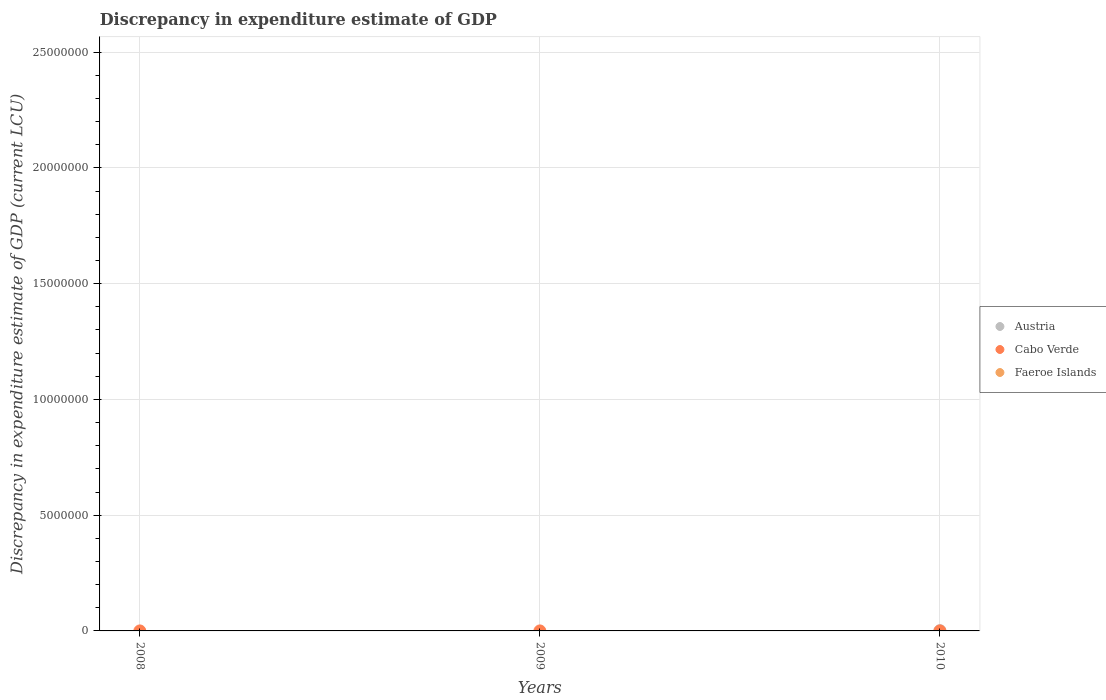How many different coloured dotlines are there?
Provide a short and direct response. 2. What is the discrepancy in expenditure estimate of GDP in Faeroe Islands in 2008?
Your answer should be compact. 0. What is the difference between the discrepancy in expenditure estimate of GDP in Cabo Verde in 2008 and that in 2009?
Your response must be concise. -100. What is the difference between the discrepancy in expenditure estimate of GDP in Cabo Verde in 2009 and the discrepancy in expenditure estimate of GDP in Austria in 2010?
Provide a short and direct response. -9900. What is the average discrepancy in expenditure estimate of GDP in Austria per year?
Offer a terse response. 3333.33. In how many years, is the discrepancy in expenditure estimate of GDP in Faeroe Islands greater than the average discrepancy in expenditure estimate of GDP in Faeroe Islands taken over all years?
Provide a short and direct response. 0. Is the sum of the discrepancy in expenditure estimate of GDP in Cabo Verde in 2008 and 2009 greater than the maximum discrepancy in expenditure estimate of GDP in Faeroe Islands across all years?
Ensure brevity in your answer.  Yes. Does the discrepancy in expenditure estimate of GDP in Faeroe Islands monotonically increase over the years?
Offer a terse response. No. Is the discrepancy in expenditure estimate of GDP in Faeroe Islands strictly less than the discrepancy in expenditure estimate of GDP in Cabo Verde over the years?
Your answer should be very brief. Yes. What is the difference between two consecutive major ticks on the Y-axis?
Your answer should be very brief. 5.00e+06. Are the values on the major ticks of Y-axis written in scientific E-notation?
Ensure brevity in your answer.  No. Does the graph contain grids?
Provide a short and direct response. Yes. How many legend labels are there?
Your answer should be very brief. 3. What is the title of the graph?
Keep it short and to the point. Discrepancy in expenditure estimate of GDP. What is the label or title of the Y-axis?
Keep it short and to the point. Discrepancy in expenditure estimate of GDP (current LCU). What is the Discrepancy in expenditure estimate of GDP (current LCU) in Austria in 2008?
Offer a very short reply. 0. What is the Discrepancy in expenditure estimate of GDP (current LCU) in Cabo Verde in 2008?
Offer a terse response. 9e-6. What is the Discrepancy in expenditure estimate of GDP (current LCU) in Austria in 2009?
Provide a short and direct response. 0. What is the Discrepancy in expenditure estimate of GDP (current LCU) in Cabo Verde in 2009?
Give a very brief answer. 100. What is the Discrepancy in expenditure estimate of GDP (current LCU) of Faeroe Islands in 2009?
Your answer should be very brief. 0. What is the Discrepancy in expenditure estimate of GDP (current LCU) of Faeroe Islands in 2010?
Ensure brevity in your answer.  0. Across all years, what is the maximum Discrepancy in expenditure estimate of GDP (current LCU) of Cabo Verde?
Offer a terse response. 100. Across all years, what is the minimum Discrepancy in expenditure estimate of GDP (current LCU) of Cabo Verde?
Make the answer very short. 0. What is the total Discrepancy in expenditure estimate of GDP (current LCU) of Cabo Verde in the graph?
Keep it short and to the point. 100. What is the total Discrepancy in expenditure estimate of GDP (current LCU) in Faeroe Islands in the graph?
Offer a very short reply. 0. What is the difference between the Discrepancy in expenditure estimate of GDP (current LCU) in Cabo Verde in 2008 and that in 2009?
Provide a short and direct response. -100. What is the average Discrepancy in expenditure estimate of GDP (current LCU) of Austria per year?
Give a very brief answer. 3333.33. What is the average Discrepancy in expenditure estimate of GDP (current LCU) of Cabo Verde per year?
Make the answer very short. 33.33. What is the average Discrepancy in expenditure estimate of GDP (current LCU) in Faeroe Islands per year?
Your response must be concise. 0. What is the ratio of the Discrepancy in expenditure estimate of GDP (current LCU) of Cabo Verde in 2008 to that in 2009?
Your answer should be very brief. 0. What is the difference between the highest and the lowest Discrepancy in expenditure estimate of GDP (current LCU) of Austria?
Ensure brevity in your answer.  10000. What is the difference between the highest and the lowest Discrepancy in expenditure estimate of GDP (current LCU) in Cabo Verde?
Ensure brevity in your answer.  100. 